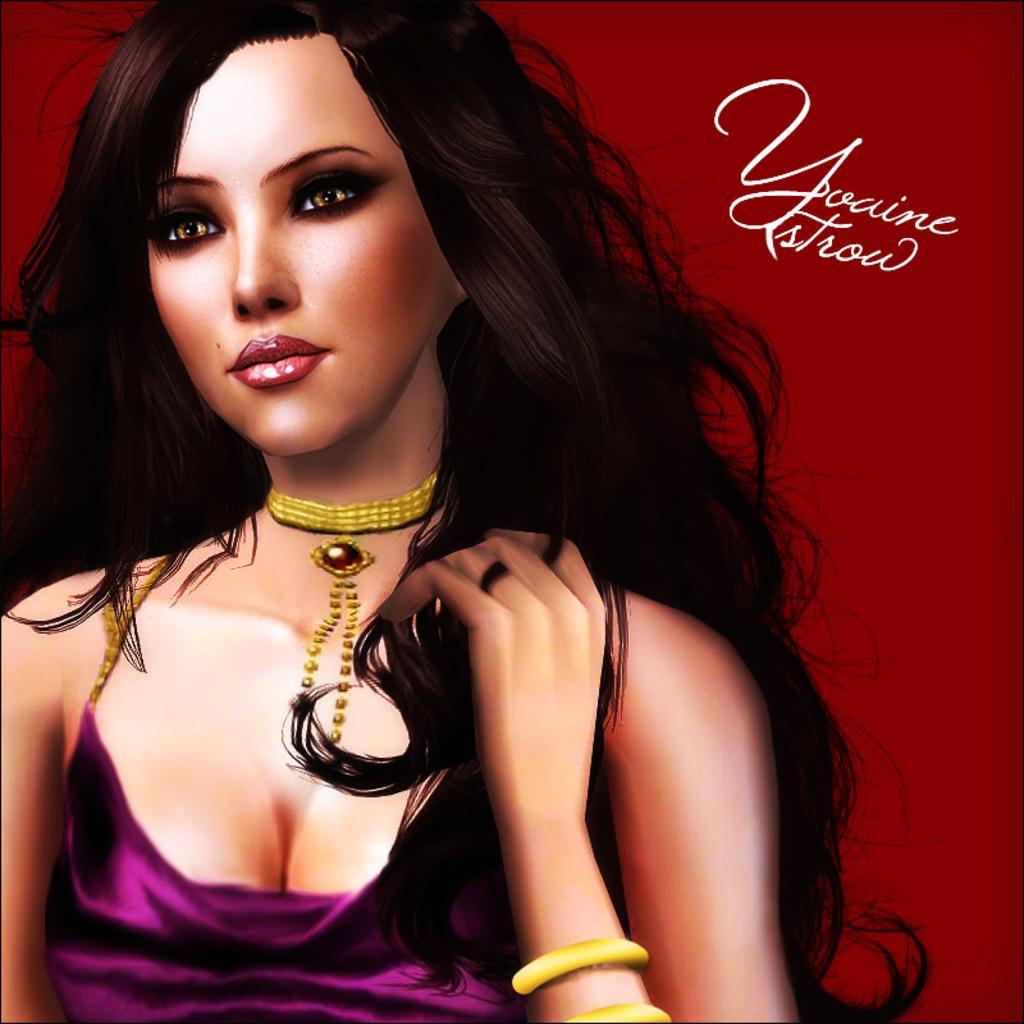Could you give a brief overview of what you see in this image? In this picture I can see an animated image of a woman and I can see text on the top right corner of the picture. 